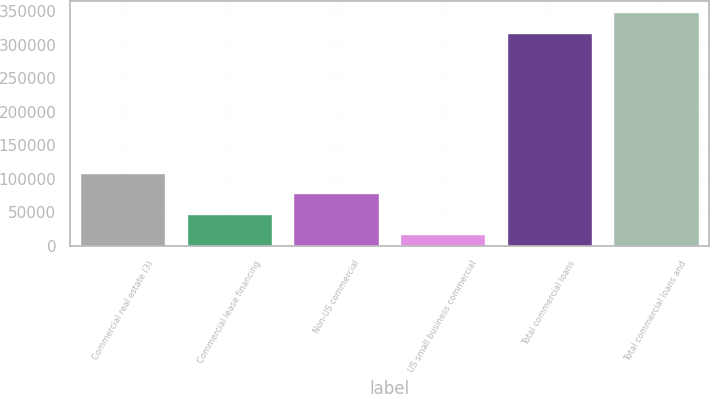Convert chart. <chart><loc_0><loc_0><loc_500><loc_500><bar_chart><fcel>Commercial real estate (3)<fcel>Commercial lease financing<fcel>Non-US commercial<fcel>US small business commercial<fcel>Total commercial loans<fcel>Total commercial loans and<nl><fcel>109037<fcel>48029.8<fcel>78533.6<fcel>17526<fcel>317628<fcel>348132<nl></chart> 